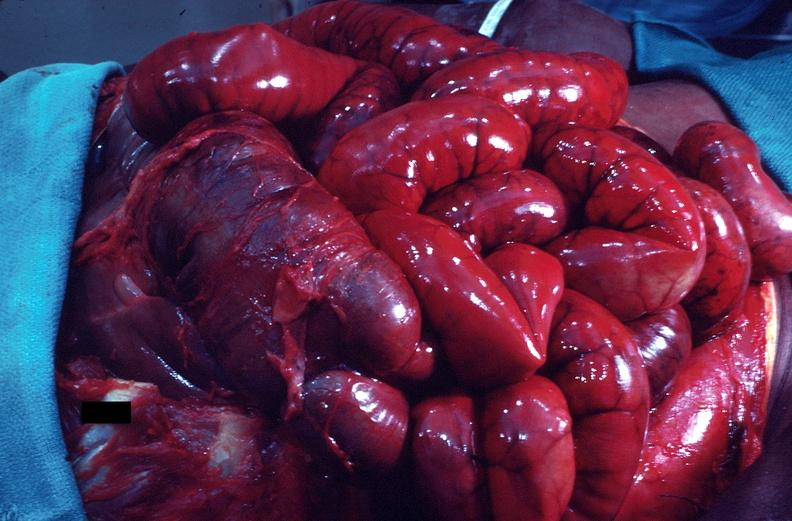does this image show intestine in situ, congestion and early ischemic necrosis?
Answer the question using a single word or phrase. Yes 